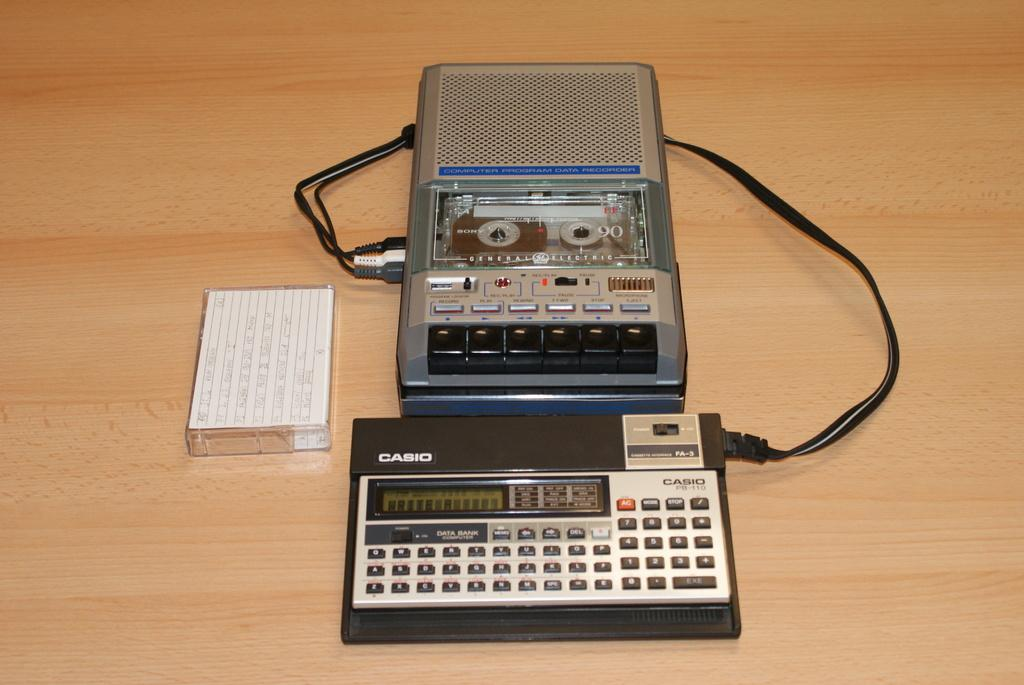<image>
Create a compact narrative representing the image presented. An old tape recorder is connected to a Casio mini keyboard. 